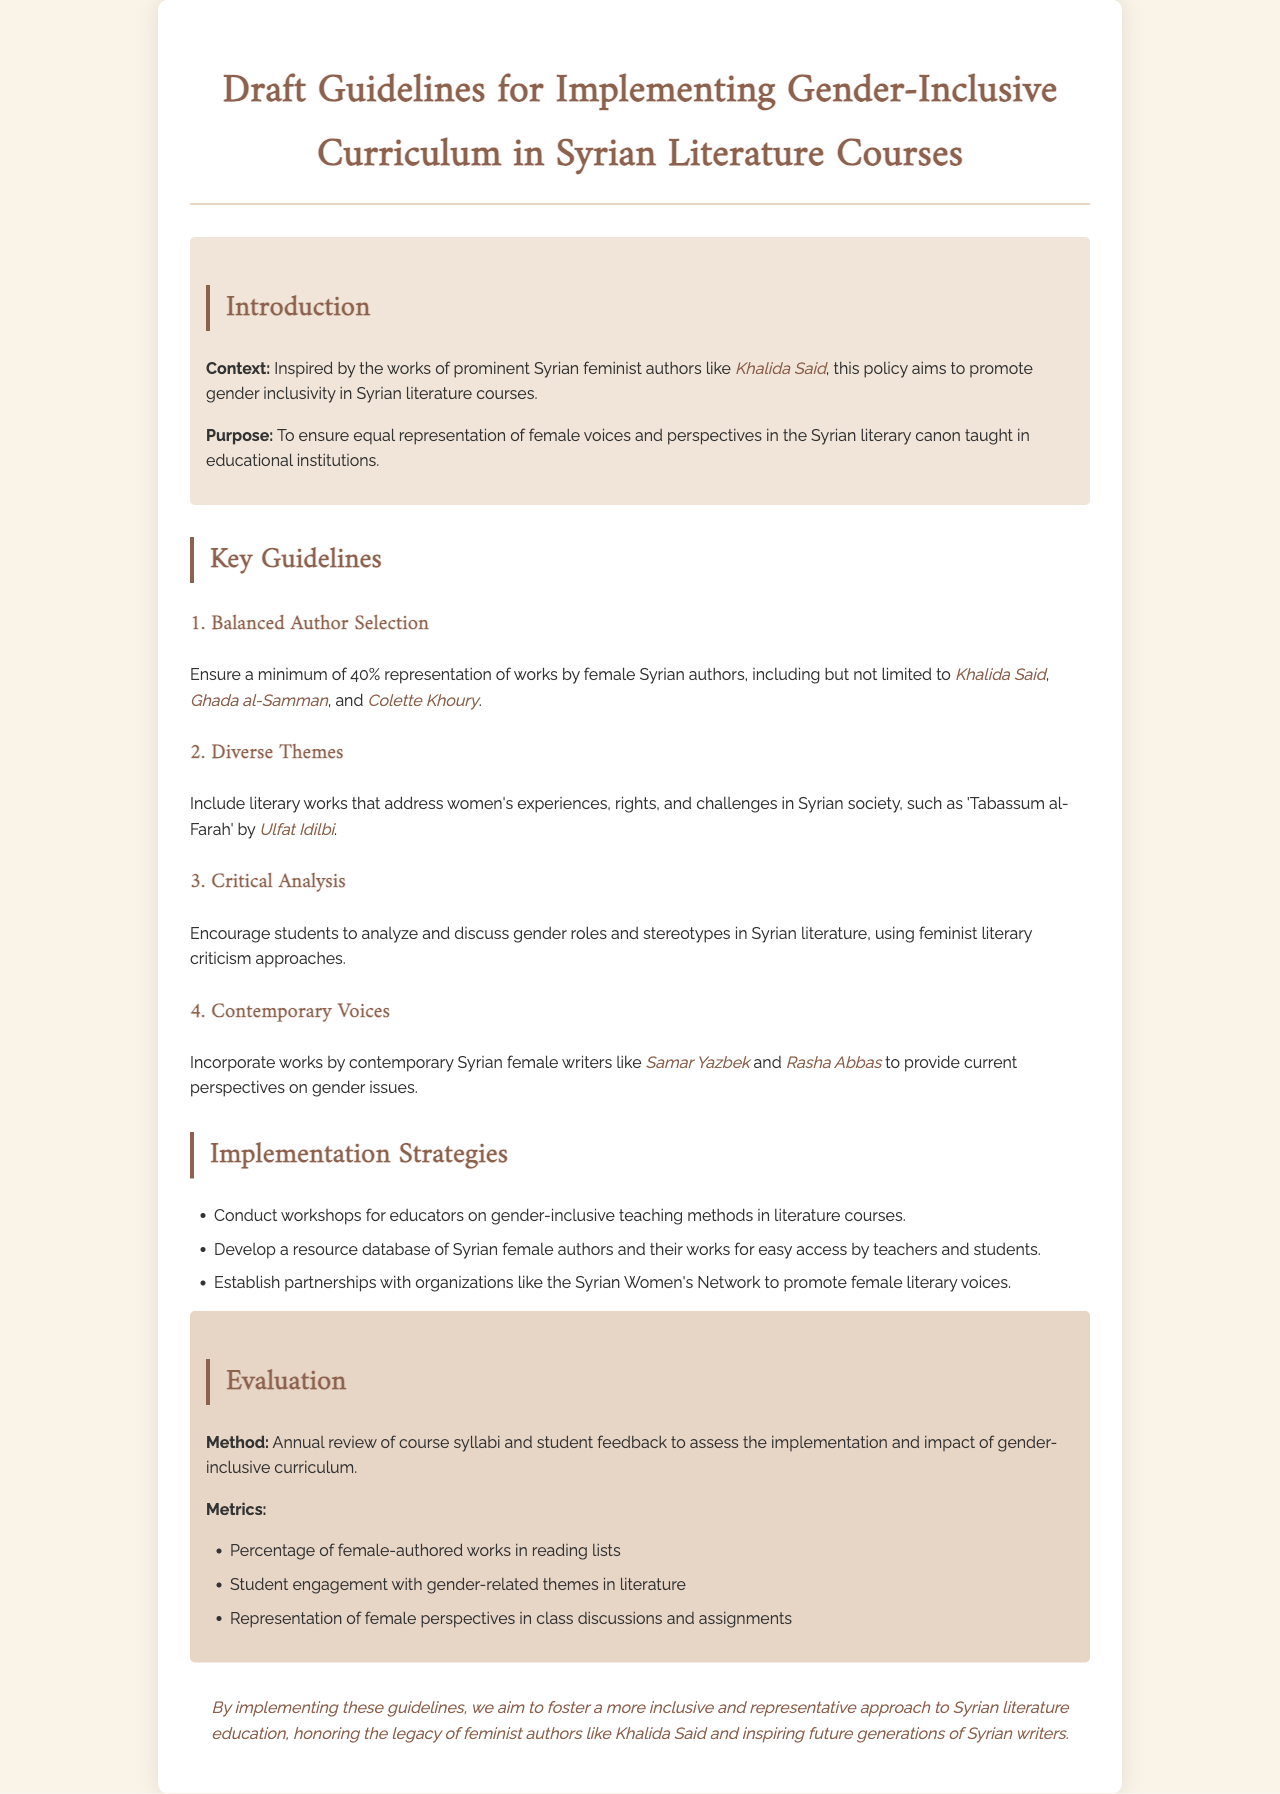What is the purpose of the guidelines? The purpose is to ensure equal representation of female voices and perspectives in the Syrian literary canon taught in educational institutions.
Answer: To ensure equal representation of female voices and perspectives in the Syrian literary canon taught in educational institutions What percentage of works by female authors is required? The document specifies a minimum representation of female Syrian authors in the selected works.
Answer: 40% Which author is mentioned alongside Khalida Said in the guidelines? The document lists other prominent Syrian feminist authors along with Khalida Said.
Answer: Ghada al-Samman What is one metric for evaluation mentioned in the document? Metrics are used to assess the implementation and impact of the gender-inclusive curriculum.
Answer: Percentage of female-authored works in reading lists What is the title of the work by Ulfat Idilbi? The document provides examples of literary works that address women's experiences and rights in Syrian society.
Answer: Tabassum al-Farah What is one implementation strategy suggested? The document lists several strategies to effectively implement the guidelines for educators.
Answer: Conduct workshops for educators on gender-inclusive teaching methods in literature courses Who are two contemporary female writers included in the guidelines? The document highlights contemporary female authors for their relevance in discussions about gender issues in literature.
Answer: Samar Yazbek and Rasha Abbas 